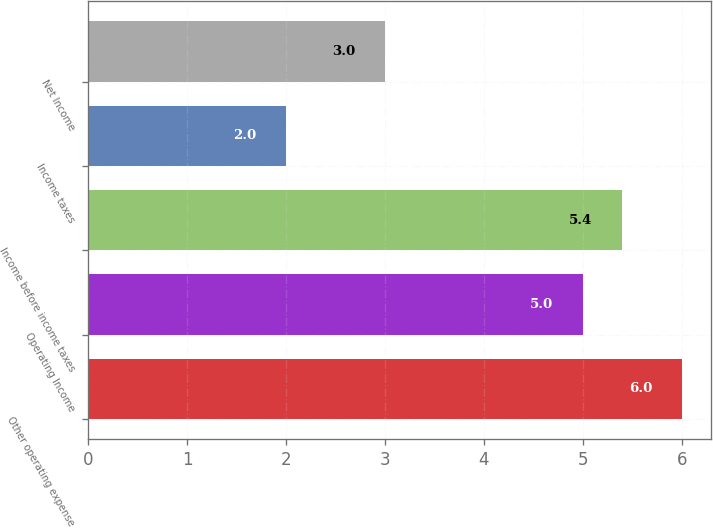Convert chart. <chart><loc_0><loc_0><loc_500><loc_500><bar_chart><fcel>Other operating expense<fcel>Operating Income<fcel>Income before income taxes<fcel>Income taxes<fcel>Net Income<nl><fcel>6<fcel>5<fcel>5.4<fcel>2<fcel>3<nl></chart> 